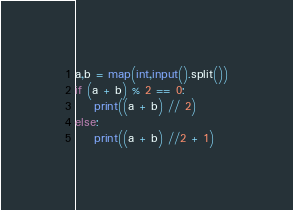<code> <loc_0><loc_0><loc_500><loc_500><_Python_>a,b = map(int,input().split())
if (a + b) % 2 == 0:
    print((a + b) // 2)
else:
    print((a + b) //2 + 1)</code> 